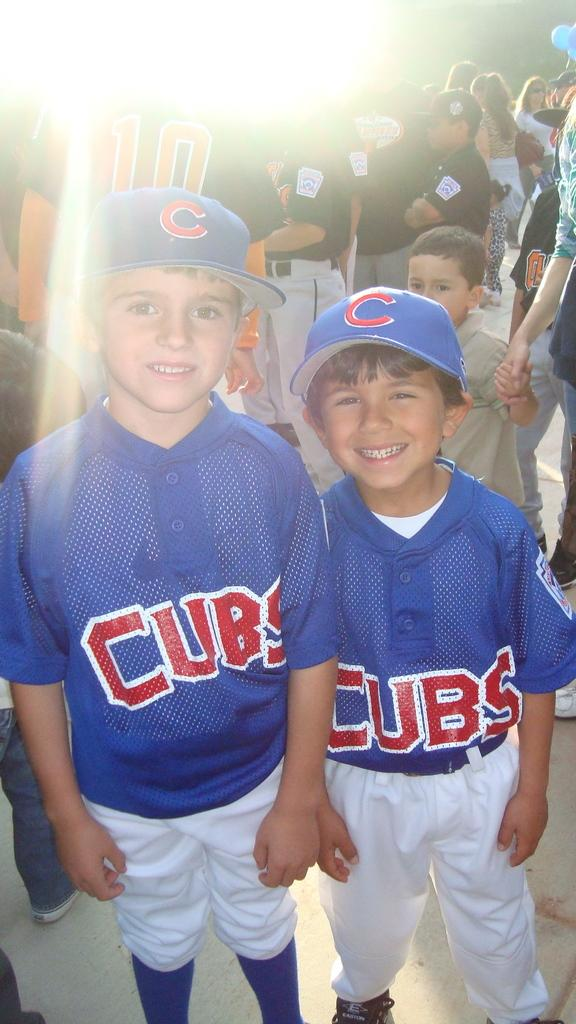<image>
Give a short and clear explanation of the subsequent image. Two boys stand next to each other with blue cubs jerseys on and other baseball players in the background. 